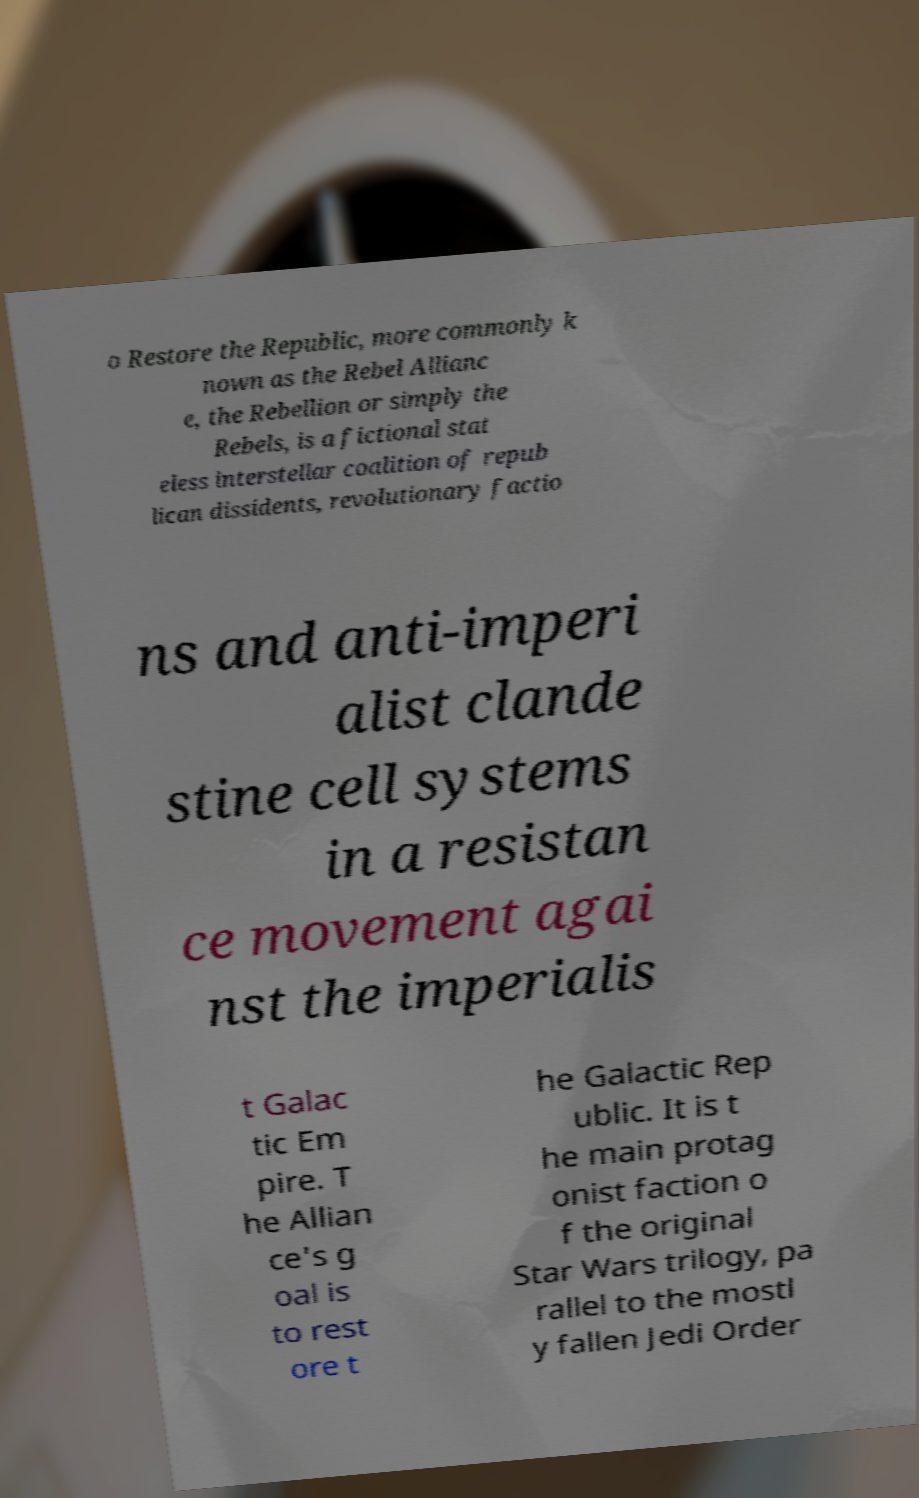Could you assist in decoding the text presented in this image and type it out clearly? o Restore the Republic, more commonly k nown as the Rebel Allianc e, the Rebellion or simply the Rebels, is a fictional stat eless interstellar coalition of repub lican dissidents, revolutionary factio ns and anti-imperi alist clande stine cell systems in a resistan ce movement agai nst the imperialis t Galac tic Em pire. T he Allian ce's g oal is to rest ore t he Galactic Rep ublic. It is t he main protag onist faction o f the original Star Wars trilogy, pa rallel to the mostl y fallen Jedi Order 